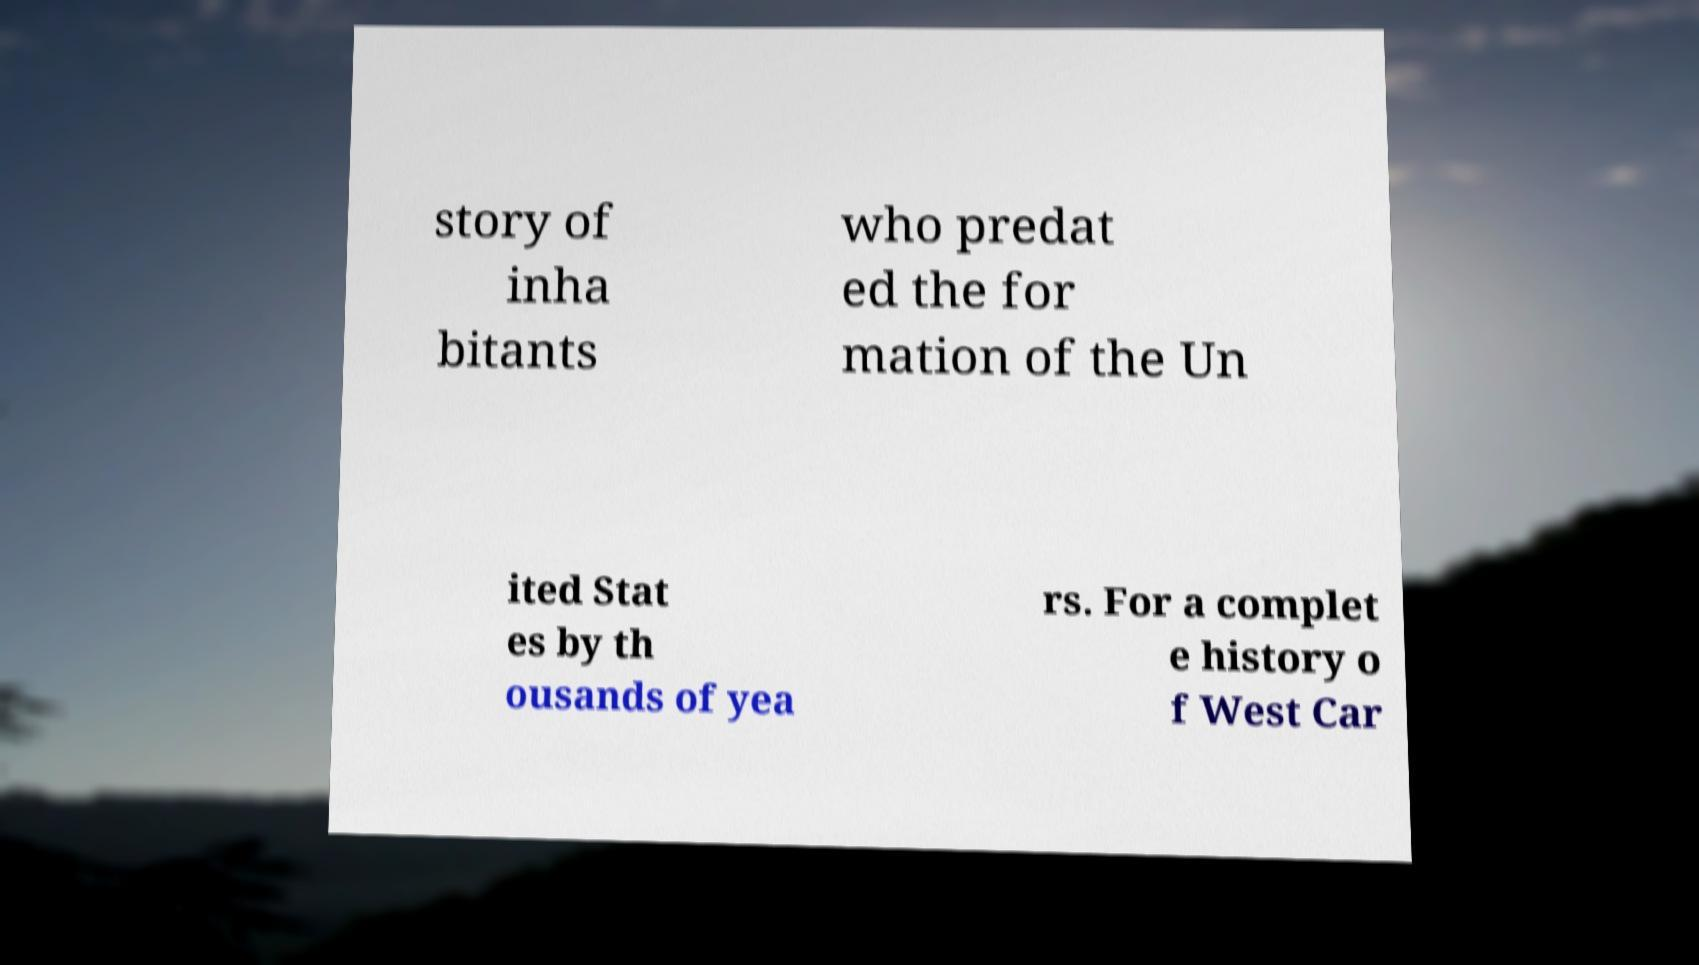For documentation purposes, I need the text within this image transcribed. Could you provide that? story of inha bitants who predat ed the for mation of the Un ited Stat es by th ousands of yea rs. For a complet e history o f West Car 